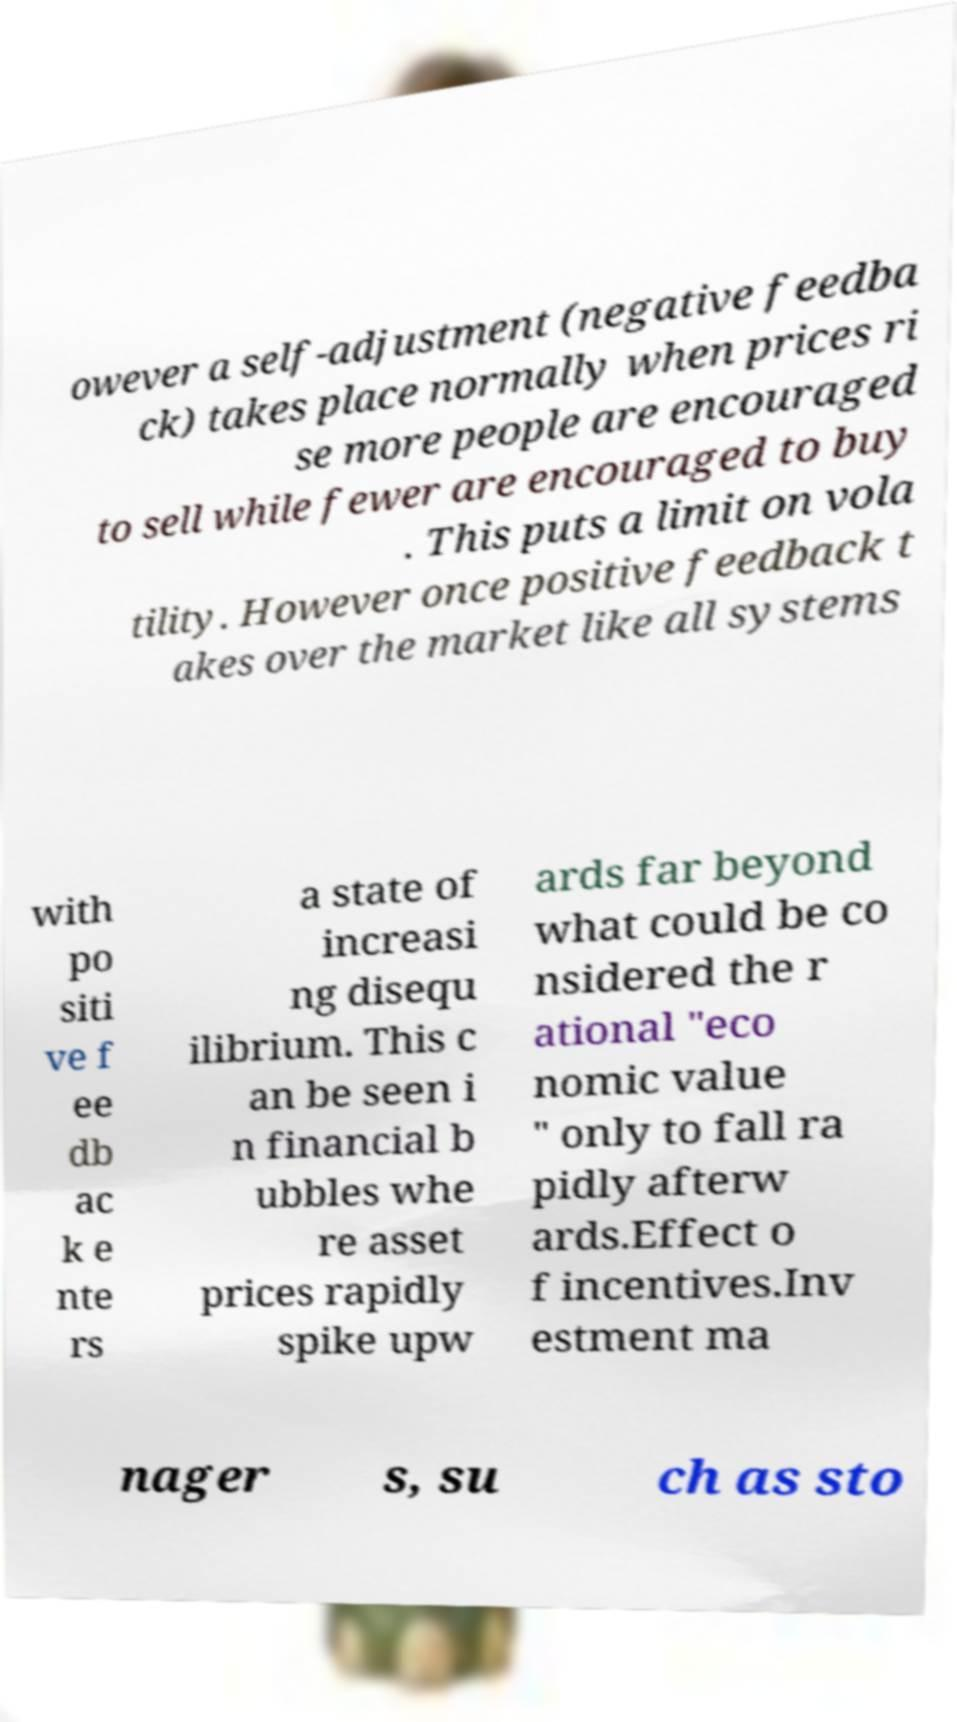Could you extract and type out the text from this image? owever a self-adjustment (negative feedba ck) takes place normally when prices ri se more people are encouraged to sell while fewer are encouraged to buy . This puts a limit on vola tility. However once positive feedback t akes over the market like all systems with po siti ve f ee db ac k e nte rs a state of increasi ng disequ ilibrium. This c an be seen i n financial b ubbles whe re asset prices rapidly spike upw ards far beyond what could be co nsidered the r ational "eco nomic value " only to fall ra pidly afterw ards.Effect o f incentives.Inv estment ma nager s, su ch as sto 